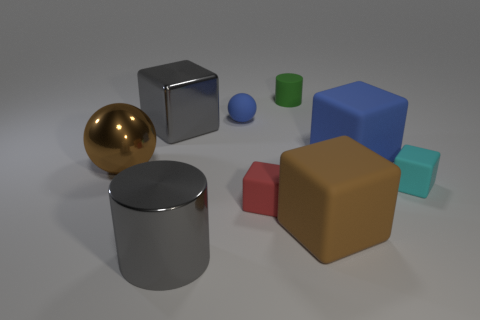What material is the tiny cyan cube?
Make the answer very short. Rubber. Does the cylinder that is in front of the cyan object have the same size as the small green matte cylinder?
Give a very brief answer. No. How many objects are either brown metallic balls or brown blocks?
Offer a very short reply. 2. What shape is the thing that is the same color as the metallic cube?
Your answer should be very brief. Cylinder. There is a rubber thing that is both left of the matte cylinder and in front of the large brown ball; what size is it?
Ensure brevity in your answer.  Small. What number of tiny blue matte objects are there?
Your response must be concise. 1. What number of blocks are large blue matte objects or small blue rubber things?
Your answer should be very brief. 1. There is a rubber block that is on the left side of the cylinder that is behind the large gray metal cylinder; how many cyan rubber cubes are in front of it?
Provide a succinct answer. 0. The ball that is the same size as the red matte block is what color?
Make the answer very short. Blue. What number of other things are the same color as the metal cylinder?
Your answer should be compact. 1. 